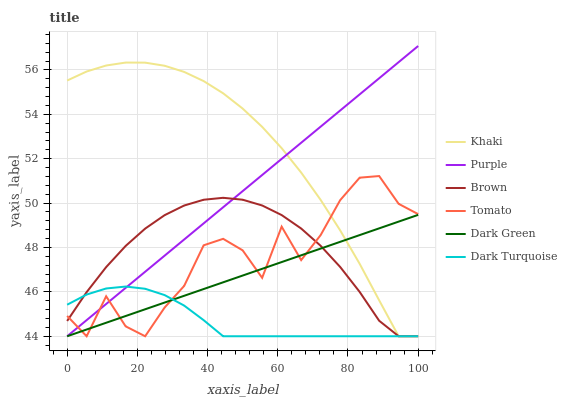Does Dark Turquoise have the minimum area under the curve?
Answer yes or no. Yes. Does Khaki have the maximum area under the curve?
Answer yes or no. Yes. Does Brown have the minimum area under the curve?
Answer yes or no. No. Does Brown have the maximum area under the curve?
Answer yes or no. No. Is Purple the smoothest?
Answer yes or no. Yes. Is Tomato the roughest?
Answer yes or no. Yes. Is Brown the smoothest?
Answer yes or no. No. Is Brown the roughest?
Answer yes or no. No. Does Tomato have the lowest value?
Answer yes or no. Yes. Does Purple have the highest value?
Answer yes or no. Yes. Does Brown have the highest value?
Answer yes or no. No. Does Brown intersect Purple?
Answer yes or no. Yes. Is Brown less than Purple?
Answer yes or no. No. Is Brown greater than Purple?
Answer yes or no. No. 